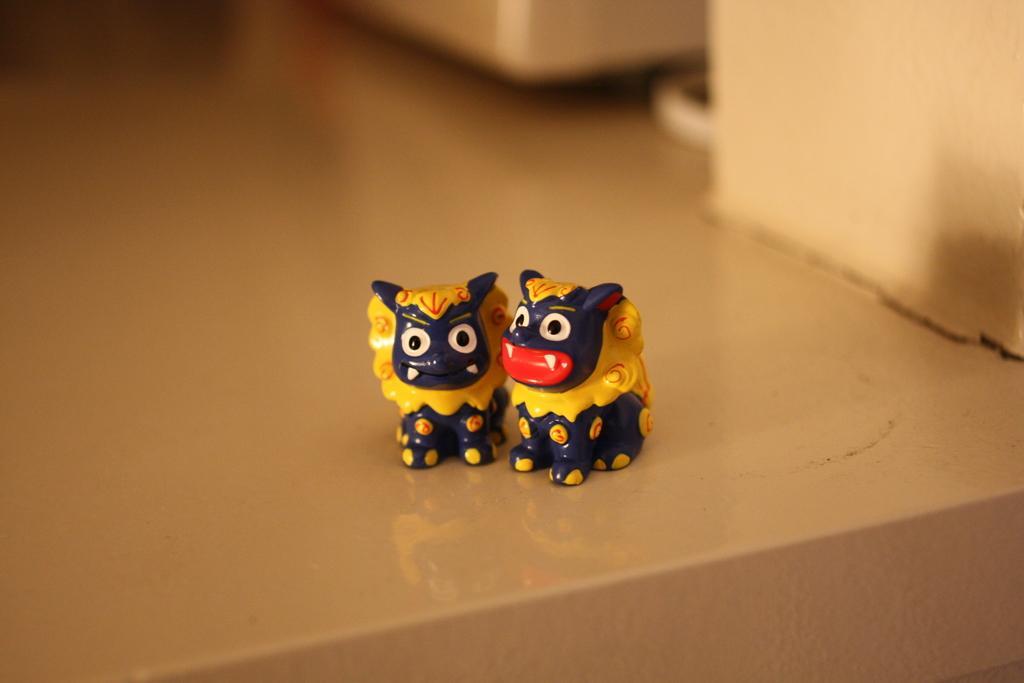Please provide a concise description of this image. In this image I can see, in the middle it looks like there are two dolls in blue and yellow color.. 